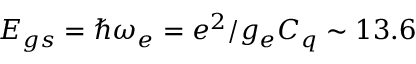<formula> <loc_0><loc_0><loc_500><loc_500>E _ { g s } = \hbar { \omega } _ { e } = e ^ { 2 } / g _ { e } C _ { q } \sim 1 3 . 6</formula> 